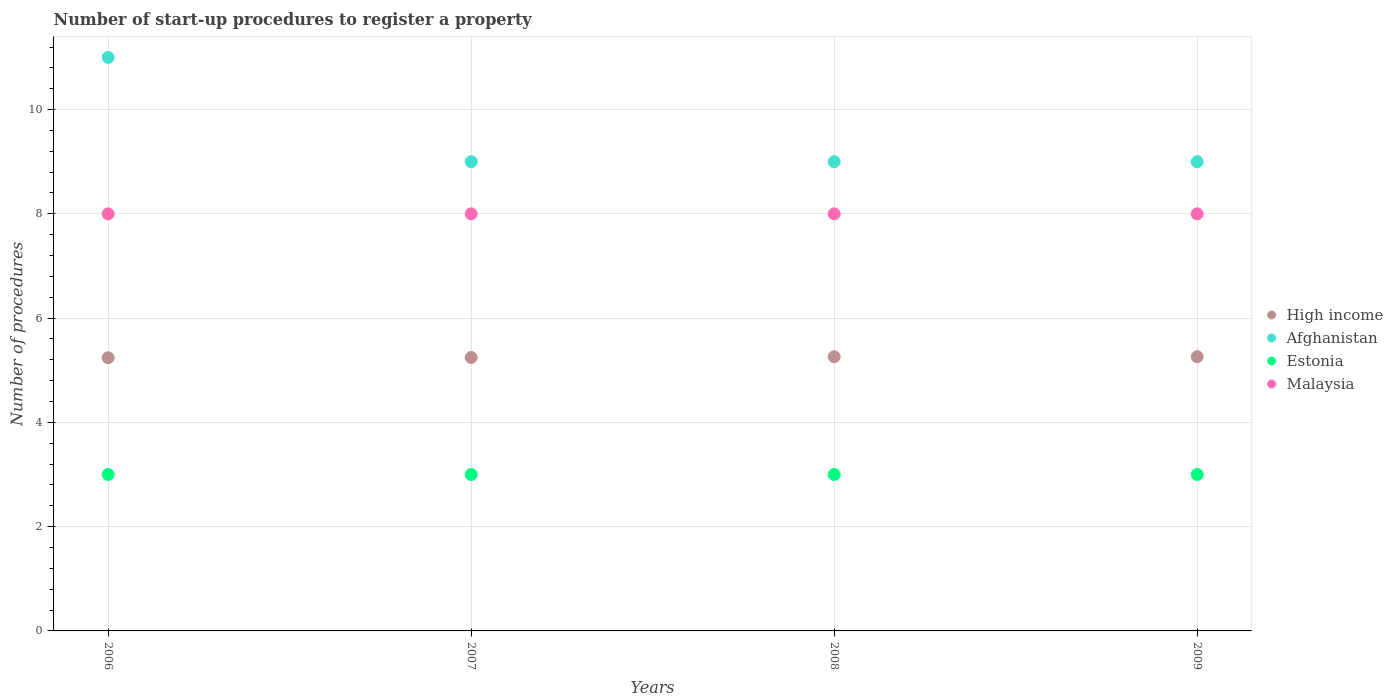How many different coloured dotlines are there?
Provide a succinct answer. 4. What is the number of procedures required to register a property in Malaysia in 2006?
Your answer should be very brief. 8. Across all years, what is the maximum number of procedures required to register a property in High income?
Your answer should be very brief. 5.26. Across all years, what is the minimum number of procedures required to register a property in Malaysia?
Keep it short and to the point. 8. In which year was the number of procedures required to register a property in Estonia maximum?
Offer a very short reply. 2006. What is the total number of procedures required to register a property in Malaysia in the graph?
Ensure brevity in your answer.  32. What is the difference between the number of procedures required to register a property in Malaysia in 2006 and the number of procedures required to register a property in Estonia in 2008?
Your answer should be very brief. 5. What is the average number of procedures required to register a property in Malaysia per year?
Keep it short and to the point. 8. In the year 2007, what is the difference between the number of procedures required to register a property in Afghanistan and number of procedures required to register a property in Malaysia?
Give a very brief answer. 1. In how many years, is the number of procedures required to register a property in High income greater than 8?
Your response must be concise. 0. What is the ratio of the number of procedures required to register a property in High income in 2006 to that in 2007?
Offer a terse response. 1. Is the difference between the number of procedures required to register a property in Afghanistan in 2006 and 2007 greater than the difference between the number of procedures required to register a property in Malaysia in 2006 and 2007?
Make the answer very short. Yes. Is it the case that in every year, the sum of the number of procedures required to register a property in Afghanistan and number of procedures required to register a property in Malaysia  is greater than the sum of number of procedures required to register a property in High income and number of procedures required to register a property in Estonia?
Make the answer very short. Yes. Does the number of procedures required to register a property in Afghanistan monotonically increase over the years?
Make the answer very short. No. Is the number of procedures required to register a property in Estonia strictly greater than the number of procedures required to register a property in Afghanistan over the years?
Offer a very short reply. No. Is the number of procedures required to register a property in Malaysia strictly less than the number of procedures required to register a property in Afghanistan over the years?
Make the answer very short. Yes. How many dotlines are there?
Provide a succinct answer. 4. Are the values on the major ticks of Y-axis written in scientific E-notation?
Offer a very short reply. No. Does the graph contain any zero values?
Offer a terse response. No. Does the graph contain grids?
Your answer should be compact. Yes. Where does the legend appear in the graph?
Your answer should be compact. Center right. How many legend labels are there?
Provide a succinct answer. 4. How are the legend labels stacked?
Offer a very short reply. Vertical. What is the title of the graph?
Your answer should be compact. Number of start-up procedures to register a property. What is the label or title of the X-axis?
Your response must be concise. Years. What is the label or title of the Y-axis?
Provide a short and direct response. Number of procedures. What is the Number of procedures in High income in 2006?
Offer a very short reply. 5.24. What is the Number of procedures of Afghanistan in 2006?
Provide a short and direct response. 11. What is the Number of procedures in Malaysia in 2006?
Offer a terse response. 8. What is the Number of procedures of High income in 2007?
Your answer should be very brief. 5.25. What is the Number of procedures in Afghanistan in 2007?
Your response must be concise. 9. What is the Number of procedures of Estonia in 2007?
Give a very brief answer. 3. What is the Number of procedures in High income in 2008?
Provide a short and direct response. 5.26. What is the Number of procedures of Estonia in 2008?
Provide a succinct answer. 3. What is the Number of procedures in Malaysia in 2008?
Ensure brevity in your answer.  8. What is the Number of procedures in High income in 2009?
Offer a very short reply. 5.26. What is the Number of procedures in Estonia in 2009?
Offer a very short reply. 3. What is the Number of procedures in Malaysia in 2009?
Offer a very short reply. 8. Across all years, what is the maximum Number of procedures of High income?
Make the answer very short. 5.26. Across all years, what is the maximum Number of procedures in Afghanistan?
Offer a terse response. 11. Across all years, what is the maximum Number of procedures of Estonia?
Give a very brief answer. 3. Across all years, what is the minimum Number of procedures of High income?
Ensure brevity in your answer.  5.24. What is the total Number of procedures of High income in the graph?
Your response must be concise. 21. What is the total Number of procedures of Afghanistan in the graph?
Your answer should be compact. 38. What is the total Number of procedures of Estonia in the graph?
Provide a succinct answer. 12. What is the total Number of procedures in Malaysia in the graph?
Offer a very short reply. 32. What is the difference between the Number of procedures of High income in 2006 and that in 2007?
Keep it short and to the point. -0.01. What is the difference between the Number of procedures of High income in 2006 and that in 2008?
Ensure brevity in your answer.  -0.02. What is the difference between the Number of procedures in Estonia in 2006 and that in 2008?
Provide a succinct answer. 0. What is the difference between the Number of procedures of High income in 2006 and that in 2009?
Your answer should be very brief. -0.02. What is the difference between the Number of procedures in High income in 2007 and that in 2008?
Provide a short and direct response. -0.01. What is the difference between the Number of procedures of Afghanistan in 2007 and that in 2008?
Offer a very short reply. 0. What is the difference between the Number of procedures of High income in 2007 and that in 2009?
Ensure brevity in your answer.  -0.01. What is the difference between the Number of procedures in Estonia in 2007 and that in 2009?
Make the answer very short. 0. What is the difference between the Number of procedures of Malaysia in 2007 and that in 2009?
Provide a succinct answer. 0. What is the difference between the Number of procedures in Afghanistan in 2008 and that in 2009?
Your response must be concise. 0. What is the difference between the Number of procedures in High income in 2006 and the Number of procedures in Afghanistan in 2007?
Your response must be concise. -3.76. What is the difference between the Number of procedures in High income in 2006 and the Number of procedures in Estonia in 2007?
Keep it short and to the point. 2.24. What is the difference between the Number of procedures in High income in 2006 and the Number of procedures in Malaysia in 2007?
Offer a terse response. -2.76. What is the difference between the Number of procedures of Afghanistan in 2006 and the Number of procedures of Estonia in 2007?
Give a very brief answer. 8. What is the difference between the Number of procedures of Estonia in 2006 and the Number of procedures of Malaysia in 2007?
Give a very brief answer. -5. What is the difference between the Number of procedures in High income in 2006 and the Number of procedures in Afghanistan in 2008?
Your answer should be very brief. -3.76. What is the difference between the Number of procedures of High income in 2006 and the Number of procedures of Estonia in 2008?
Your answer should be compact. 2.24. What is the difference between the Number of procedures in High income in 2006 and the Number of procedures in Malaysia in 2008?
Make the answer very short. -2.76. What is the difference between the Number of procedures of Afghanistan in 2006 and the Number of procedures of Estonia in 2008?
Give a very brief answer. 8. What is the difference between the Number of procedures in Afghanistan in 2006 and the Number of procedures in Malaysia in 2008?
Provide a short and direct response. 3. What is the difference between the Number of procedures of Estonia in 2006 and the Number of procedures of Malaysia in 2008?
Give a very brief answer. -5. What is the difference between the Number of procedures of High income in 2006 and the Number of procedures of Afghanistan in 2009?
Offer a very short reply. -3.76. What is the difference between the Number of procedures in High income in 2006 and the Number of procedures in Estonia in 2009?
Offer a terse response. 2.24. What is the difference between the Number of procedures of High income in 2006 and the Number of procedures of Malaysia in 2009?
Offer a very short reply. -2.76. What is the difference between the Number of procedures of Afghanistan in 2006 and the Number of procedures of Malaysia in 2009?
Ensure brevity in your answer.  3. What is the difference between the Number of procedures in High income in 2007 and the Number of procedures in Afghanistan in 2008?
Offer a very short reply. -3.75. What is the difference between the Number of procedures of High income in 2007 and the Number of procedures of Estonia in 2008?
Make the answer very short. 2.25. What is the difference between the Number of procedures in High income in 2007 and the Number of procedures in Malaysia in 2008?
Ensure brevity in your answer.  -2.75. What is the difference between the Number of procedures of High income in 2007 and the Number of procedures of Afghanistan in 2009?
Offer a terse response. -3.75. What is the difference between the Number of procedures of High income in 2007 and the Number of procedures of Estonia in 2009?
Offer a very short reply. 2.25. What is the difference between the Number of procedures in High income in 2007 and the Number of procedures in Malaysia in 2009?
Offer a terse response. -2.75. What is the difference between the Number of procedures in Afghanistan in 2007 and the Number of procedures in Estonia in 2009?
Offer a very short reply. 6. What is the difference between the Number of procedures of Afghanistan in 2007 and the Number of procedures of Malaysia in 2009?
Your answer should be very brief. 1. What is the difference between the Number of procedures in High income in 2008 and the Number of procedures in Afghanistan in 2009?
Your answer should be very brief. -3.74. What is the difference between the Number of procedures in High income in 2008 and the Number of procedures in Estonia in 2009?
Provide a short and direct response. 2.26. What is the difference between the Number of procedures in High income in 2008 and the Number of procedures in Malaysia in 2009?
Give a very brief answer. -2.74. What is the average Number of procedures in High income per year?
Provide a short and direct response. 5.25. What is the average Number of procedures of Afghanistan per year?
Offer a very short reply. 9.5. What is the average Number of procedures of Estonia per year?
Provide a short and direct response. 3. What is the average Number of procedures of Malaysia per year?
Provide a short and direct response. 8. In the year 2006, what is the difference between the Number of procedures of High income and Number of procedures of Afghanistan?
Your response must be concise. -5.76. In the year 2006, what is the difference between the Number of procedures in High income and Number of procedures in Estonia?
Give a very brief answer. 2.24. In the year 2006, what is the difference between the Number of procedures in High income and Number of procedures in Malaysia?
Offer a terse response. -2.76. In the year 2006, what is the difference between the Number of procedures in Afghanistan and Number of procedures in Estonia?
Offer a terse response. 8. In the year 2006, what is the difference between the Number of procedures of Afghanistan and Number of procedures of Malaysia?
Offer a terse response. 3. In the year 2006, what is the difference between the Number of procedures of Estonia and Number of procedures of Malaysia?
Offer a terse response. -5. In the year 2007, what is the difference between the Number of procedures of High income and Number of procedures of Afghanistan?
Make the answer very short. -3.75. In the year 2007, what is the difference between the Number of procedures in High income and Number of procedures in Estonia?
Keep it short and to the point. 2.25. In the year 2007, what is the difference between the Number of procedures in High income and Number of procedures in Malaysia?
Your answer should be very brief. -2.75. In the year 2007, what is the difference between the Number of procedures of Estonia and Number of procedures of Malaysia?
Your response must be concise. -5. In the year 2008, what is the difference between the Number of procedures of High income and Number of procedures of Afghanistan?
Your answer should be compact. -3.74. In the year 2008, what is the difference between the Number of procedures in High income and Number of procedures in Estonia?
Make the answer very short. 2.26. In the year 2008, what is the difference between the Number of procedures of High income and Number of procedures of Malaysia?
Give a very brief answer. -2.74. In the year 2008, what is the difference between the Number of procedures in Afghanistan and Number of procedures in Estonia?
Keep it short and to the point. 6. In the year 2008, what is the difference between the Number of procedures in Estonia and Number of procedures in Malaysia?
Give a very brief answer. -5. In the year 2009, what is the difference between the Number of procedures of High income and Number of procedures of Afghanistan?
Keep it short and to the point. -3.74. In the year 2009, what is the difference between the Number of procedures of High income and Number of procedures of Estonia?
Your answer should be compact. 2.26. In the year 2009, what is the difference between the Number of procedures in High income and Number of procedures in Malaysia?
Give a very brief answer. -2.74. What is the ratio of the Number of procedures of High income in 2006 to that in 2007?
Ensure brevity in your answer.  1. What is the ratio of the Number of procedures of Afghanistan in 2006 to that in 2007?
Provide a succinct answer. 1.22. What is the ratio of the Number of procedures in Malaysia in 2006 to that in 2007?
Your answer should be very brief. 1. What is the ratio of the Number of procedures in Afghanistan in 2006 to that in 2008?
Give a very brief answer. 1.22. What is the ratio of the Number of procedures in Estonia in 2006 to that in 2008?
Provide a succinct answer. 1. What is the ratio of the Number of procedures in Malaysia in 2006 to that in 2008?
Offer a very short reply. 1. What is the ratio of the Number of procedures in Afghanistan in 2006 to that in 2009?
Your answer should be compact. 1.22. What is the ratio of the Number of procedures in Malaysia in 2006 to that in 2009?
Your answer should be compact. 1. What is the ratio of the Number of procedures in Afghanistan in 2007 to that in 2008?
Your response must be concise. 1. What is the ratio of the Number of procedures of Malaysia in 2007 to that in 2008?
Provide a succinct answer. 1. What is the ratio of the Number of procedures in High income in 2007 to that in 2009?
Your answer should be very brief. 1. What is the ratio of the Number of procedures in Estonia in 2007 to that in 2009?
Offer a terse response. 1. What is the ratio of the Number of procedures of Malaysia in 2007 to that in 2009?
Your answer should be compact. 1. What is the ratio of the Number of procedures in Malaysia in 2008 to that in 2009?
Offer a terse response. 1. What is the difference between the highest and the second highest Number of procedures in Afghanistan?
Ensure brevity in your answer.  2. What is the difference between the highest and the second highest Number of procedures in Malaysia?
Offer a terse response. 0. What is the difference between the highest and the lowest Number of procedures of High income?
Ensure brevity in your answer.  0.02. What is the difference between the highest and the lowest Number of procedures of Afghanistan?
Provide a short and direct response. 2. 